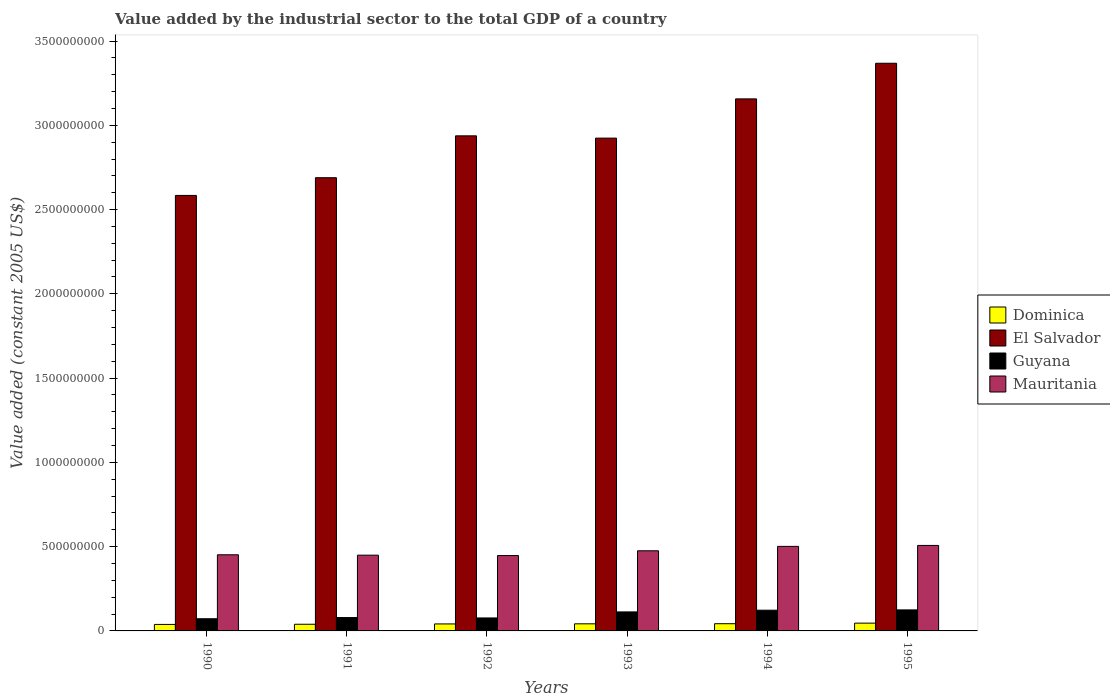How many different coloured bars are there?
Offer a very short reply. 4. How many groups of bars are there?
Your response must be concise. 6. Are the number of bars per tick equal to the number of legend labels?
Keep it short and to the point. Yes. Are the number of bars on each tick of the X-axis equal?
Ensure brevity in your answer.  Yes. How many bars are there on the 1st tick from the right?
Provide a succinct answer. 4. What is the label of the 1st group of bars from the left?
Ensure brevity in your answer.  1990. What is the value added by the industrial sector in Guyana in 1993?
Provide a succinct answer. 1.13e+08. Across all years, what is the maximum value added by the industrial sector in Mauritania?
Ensure brevity in your answer.  5.07e+08. Across all years, what is the minimum value added by the industrial sector in Guyana?
Your answer should be compact. 7.23e+07. What is the total value added by the industrial sector in Guyana in the graph?
Your response must be concise. 5.89e+08. What is the difference between the value added by the industrial sector in Guyana in 1992 and that in 1994?
Your answer should be very brief. -4.60e+07. What is the difference between the value added by the industrial sector in Dominica in 1992 and the value added by the industrial sector in Mauritania in 1995?
Offer a terse response. -4.66e+08. What is the average value added by the industrial sector in Guyana per year?
Make the answer very short. 9.82e+07. In the year 1995, what is the difference between the value added by the industrial sector in Guyana and value added by the industrial sector in Dominica?
Give a very brief answer. 7.85e+07. In how many years, is the value added by the industrial sector in Dominica greater than 2400000000 US$?
Provide a succinct answer. 0. What is the ratio of the value added by the industrial sector in El Salvador in 1991 to that in 1992?
Offer a terse response. 0.92. Is the value added by the industrial sector in Guyana in 1994 less than that in 1995?
Offer a very short reply. Yes. Is the difference between the value added by the industrial sector in Guyana in 1991 and 1993 greater than the difference between the value added by the industrial sector in Dominica in 1991 and 1993?
Keep it short and to the point. No. What is the difference between the highest and the second highest value added by the industrial sector in El Salvador?
Provide a short and direct response. 2.11e+08. What is the difference between the highest and the lowest value added by the industrial sector in El Salvador?
Your answer should be very brief. 7.84e+08. In how many years, is the value added by the industrial sector in Guyana greater than the average value added by the industrial sector in Guyana taken over all years?
Make the answer very short. 3. Is it the case that in every year, the sum of the value added by the industrial sector in Mauritania and value added by the industrial sector in Dominica is greater than the sum of value added by the industrial sector in Guyana and value added by the industrial sector in El Salvador?
Give a very brief answer. Yes. What does the 1st bar from the left in 1995 represents?
Your response must be concise. Dominica. What does the 3rd bar from the right in 1994 represents?
Ensure brevity in your answer.  El Salvador. Are all the bars in the graph horizontal?
Ensure brevity in your answer.  No. Does the graph contain any zero values?
Make the answer very short. No. Where does the legend appear in the graph?
Provide a short and direct response. Center right. How many legend labels are there?
Your response must be concise. 4. How are the legend labels stacked?
Offer a very short reply. Vertical. What is the title of the graph?
Ensure brevity in your answer.  Value added by the industrial sector to the total GDP of a country. Does "Small states" appear as one of the legend labels in the graph?
Ensure brevity in your answer.  No. What is the label or title of the X-axis?
Offer a terse response. Years. What is the label or title of the Y-axis?
Offer a very short reply. Value added (constant 2005 US$). What is the Value added (constant 2005 US$) of Dominica in 1990?
Provide a short and direct response. 3.85e+07. What is the Value added (constant 2005 US$) in El Salvador in 1990?
Offer a terse response. 2.58e+09. What is the Value added (constant 2005 US$) of Guyana in 1990?
Provide a succinct answer. 7.23e+07. What is the Value added (constant 2005 US$) of Mauritania in 1990?
Keep it short and to the point. 4.52e+08. What is the Value added (constant 2005 US$) of Dominica in 1991?
Provide a short and direct response. 3.95e+07. What is the Value added (constant 2005 US$) in El Salvador in 1991?
Your response must be concise. 2.69e+09. What is the Value added (constant 2005 US$) in Guyana in 1991?
Your answer should be very brief. 7.93e+07. What is the Value added (constant 2005 US$) in Mauritania in 1991?
Keep it short and to the point. 4.49e+08. What is the Value added (constant 2005 US$) in Dominica in 1992?
Keep it short and to the point. 4.14e+07. What is the Value added (constant 2005 US$) in El Salvador in 1992?
Give a very brief answer. 2.94e+09. What is the Value added (constant 2005 US$) in Guyana in 1992?
Provide a short and direct response. 7.70e+07. What is the Value added (constant 2005 US$) of Mauritania in 1992?
Your response must be concise. 4.47e+08. What is the Value added (constant 2005 US$) of Dominica in 1993?
Give a very brief answer. 4.22e+07. What is the Value added (constant 2005 US$) of El Salvador in 1993?
Offer a very short reply. 2.92e+09. What is the Value added (constant 2005 US$) of Guyana in 1993?
Give a very brief answer. 1.13e+08. What is the Value added (constant 2005 US$) of Mauritania in 1993?
Ensure brevity in your answer.  4.75e+08. What is the Value added (constant 2005 US$) of Dominica in 1994?
Offer a terse response. 4.28e+07. What is the Value added (constant 2005 US$) in El Salvador in 1994?
Your answer should be very brief. 3.16e+09. What is the Value added (constant 2005 US$) of Guyana in 1994?
Offer a terse response. 1.23e+08. What is the Value added (constant 2005 US$) of Mauritania in 1994?
Make the answer very short. 5.02e+08. What is the Value added (constant 2005 US$) of Dominica in 1995?
Offer a very short reply. 4.62e+07. What is the Value added (constant 2005 US$) in El Salvador in 1995?
Provide a short and direct response. 3.37e+09. What is the Value added (constant 2005 US$) of Guyana in 1995?
Ensure brevity in your answer.  1.25e+08. What is the Value added (constant 2005 US$) in Mauritania in 1995?
Make the answer very short. 5.07e+08. Across all years, what is the maximum Value added (constant 2005 US$) in Dominica?
Offer a very short reply. 4.62e+07. Across all years, what is the maximum Value added (constant 2005 US$) in El Salvador?
Your answer should be very brief. 3.37e+09. Across all years, what is the maximum Value added (constant 2005 US$) of Guyana?
Give a very brief answer. 1.25e+08. Across all years, what is the maximum Value added (constant 2005 US$) in Mauritania?
Offer a very short reply. 5.07e+08. Across all years, what is the minimum Value added (constant 2005 US$) of Dominica?
Your answer should be compact. 3.85e+07. Across all years, what is the minimum Value added (constant 2005 US$) in El Salvador?
Offer a very short reply. 2.58e+09. Across all years, what is the minimum Value added (constant 2005 US$) in Guyana?
Offer a terse response. 7.23e+07. Across all years, what is the minimum Value added (constant 2005 US$) in Mauritania?
Offer a terse response. 4.47e+08. What is the total Value added (constant 2005 US$) of Dominica in the graph?
Provide a short and direct response. 2.51e+08. What is the total Value added (constant 2005 US$) in El Salvador in the graph?
Your answer should be very brief. 1.77e+1. What is the total Value added (constant 2005 US$) in Guyana in the graph?
Your answer should be compact. 5.89e+08. What is the total Value added (constant 2005 US$) of Mauritania in the graph?
Offer a very short reply. 2.83e+09. What is the difference between the Value added (constant 2005 US$) of Dominica in 1990 and that in 1991?
Your response must be concise. -1.04e+06. What is the difference between the Value added (constant 2005 US$) in El Salvador in 1990 and that in 1991?
Provide a succinct answer. -1.05e+08. What is the difference between the Value added (constant 2005 US$) in Guyana in 1990 and that in 1991?
Provide a succinct answer. -7.01e+06. What is the difference between the Value added (constant 2005 US$) of Mauritania in 1990 and that in 1991?
Provide a short and direct response. 2.39e+06. What is the difference between the Value added (constant 2005 US$) in Dominica in 1990 and that in 1992?
Your response must be concise. -2.97e+06. What is the difference between the Value added (constant 2005 US$) of El Salvador in 1990 and that in 1992?
Your answer should be very brief. -3.54e+08. What is the difference between the Value added (constant 2005 US$) of Guyana in 1990 and that in 1992?
Provide a succinct answer. -4.70e+06. What is the difference between the Value added (constant 2005 US$) of Mauritania in 1990 and that in 1992?
Give a very brief answer. 4.77e+06. What is the difference between the Value added (constant 2005 US$) of Dominica in 1990 and that in 1993?
Your answer should be compact. -3.69e+06. What is the difference between the Value added (constant 2005 US$) of El Salvador in 1990 and that in 1993?
Your answer should be compact. -3.40e+08. What is the difference between the Value added (constant 2005 US$) of Guyana in 1990 and that in 1993?
Offer a very short reply. -4.05e+07. What is the difference between the Value added (constant 2005 US$) in Mauritania in 1990 and that in 1993?
Provide a succinct answer. -2.36e+07. What is the difference between the Value added (constant 2005 US$) in Dominica in 1990 and that in 1994?
Give a very brief answer. -4.34e+06. What is the difference between the Value added (constant 2005 US$) in El Salvador in 1990 and that in 1994?
Your answer should be very brief. -5.73e+08. What is the difference between the Value added (constant 2005 US$) of Guyana in 1990 and that in 1994?
Make the answer very short. -5.07e+07. What is the difference between the Value added (constant 2005 US$) of Mauritania in 1990 and that in 1994?
Give a very brief answer. -4.98e+07. What is the difference between the Value added (constant 2005 US$) of Dominica in 1990 and that in 1995?
Your answer should be very brief. -7.71e+06. What is the difference between the Value added (constant 2005 US$) in El Salvador in 1990 and that in 1995?
Your response must be concise. -7.84e+08. What is the difference between the Value added (constant 2005 US$) of Guyana in 1990 and that in 1995?
Offer a terse response. -5.24e+07. What is the difference between the Value added (constant 2005 US$) in Mauritania in 1990 and that in 1995?
Provide a short and direct response. -5.54e+07. What is the difference between the Value added (constant 2005 US$) of Dominica in 1991 and that in 1992?
Make the answer very short. -1.93e+06. What is the difference between the Value added (constant 2005 US$) of El Salvador in 1991 and that in 1992?
Your answer should be very brief. -2.48e+08. What is the difference between the Value added (constant 2005 US$) of Guyana in 1991 and that in 1992?
Keep it short and to the point. 2.31e+06. What is the difference between the Value added (constant 2005 US$) of Mauritania in 1991 and that in 1992?
Ensure brevity in your answer.  2.38e+06. What is the difference between the Value added (constant 2005 US$) in Dominica in 1991 and that in 1993?
Your answer should be compact. -2.65e+06. What is the difference between the Value added (constant 2005 US$) of El Salvador in 1991 and that in 1993?
Your answer should be compact. -2.35e+08. What is the difference between the Value added (constant 2005 US$) in Guyana in 1991 and that in 1993?
Offer a very short reply. -3.34e+07. What is the difference between the Value added (constant 2005 US$) in Mauritania in 1991 and that in 1993?
Make the answer very short. -2.60e+07. What is the difference between the Value added (constant 2005 US$) in Dominica in 1991 and that in 1994?
Your answer should be compact. -3.30e+06. What is the difference between the Value added (constant 2005 US$) in El Salvador in 1991 and that in 1994?
Give a very brief answer. -4.68e+08. What is the difference between the Value added (constant 2005 US$) in Guyana in 1991 and that in 1994?
Your answer should be compact. -4.36e+07. What is the difference between the Value added (constant 2005 US$) in Mauritania in 1991 and that in 1994?
Offer a very short reply. -5.22e+07. What is the difference between the Value added (constant 2005 US$) of Dominica in 1991 and that in 1995?
Provide a short and direct response. -6.67e+06. What is the difference between the Value added (constant 2005 US$) in El Salvador in 1991 and that in 1995?
Your answer should be very brief. -6.79e+08. What is the difference between the Value added (constant 2005 US$) in Guyana in 1991 and that in 1995?
Keep it short and to the point. -4.54e+07. What is the difference between the Value added (constant 2005 US$) of Mauritania in 1991 and that in 1995?
Offer a terse response. -5.78e+07. What is the difference between the Value added (constant 2005 US$) of Dominica in 1992 and that in 1993?
Keep it short and to the point. -7.15e+05. What is the difference between the Value added (constant 2005 US$) of El Salvador in 1992 and that in 1993?
Provide a short and direct response. 1.35e+07. What is the difference between the Value added (constant 2005 US$) in Guyana in 1992 and that in 1993?
Your answer should be very brief. -3.58e+07. What is the difference between the Value added (constant 2005 US$) of Mauritania in 1992 and that in 1993?
Offer a terse response. -2.84e+07. What is the difference between the Value added (constant 2005 US$) in Dominica in 1992 and that in 1994?
Ensure brevity in your answer.  -1.36e+06. What is the difference between the Value added (constant 2005 US$) of El Salvador in 1992 and that in 1994?
Offer a very short reply. -2.19e+08. What is the difference between the Value added (constant 2005 US$) of Guyana in 1992 and that in 1994?
Your response must be concise. -4.60e+07. What is the difference between the Value added (constant 2005 US$) in Mauritania in 1992 and that in 1994?
Give a very brief answer. -5.45e+07. What is the difference between the Value added (constant 2005 US$) of Dominica in 1992 and that in 1995?
Make the answer very short. -4.74e+06. What is the difference between the Value added (constant 2005 US$) in El Salvador in 1992 and that in 1995?
Provide a succinct answer. -4.31e+08. What is the difference between the Value added (constant 2005 US$) in Guyana in 1992 and that in 1995?
Your answer should be compact. -4.77e+07. What is the difference between the Value added (constant 2005 US$) of Mauritania in 1992 and that in 1995?
Provide a short and direct response. -6.01e+07. What is the difference between the Value added (constant 2005 US$) in Dominica in 1993 and that in 1994?
Offer a very short reply. -6.48e+05. What is the difference between the Value added (constant 2005 US$) of El Salvador in 1993 and that in 1994?
Make the answer very short. -2.33e+08. What is the difference between the Value added (constant 2005 US$) in Guyana in 1993 and that in 1994?
Offer a very short reply. -1.02e+07. What is the difference between the Value added (constant 2005 US$) in Mauritania in 1993 and that in 1994?
Offer a very short reply. -2.61e+07. What is the difference between the Value added (constant 2005 US$) in Dominica in 1993 and that in 1995?
Ensure brevity in your answer.  -4.02e+06. What is the difference between the Value added (constant 2005 US$) in El Salvador in 1993 and that in 1995?
Your answer should be very brief. -4.44e+08. What is the difference between the Value added (constant 2005 US$) of Guyana in 1993 and that in 1995?
Ensure brevity in your answer.  -1.20e+07. What is the difference between the Value added (constant 2005 US$) in Mauritania in 1993 and that in 1995?
Make the answer very short. -3.18e+07. What is the difference between the Value added (constant 2005 US$) of Dominica in 1994 and that in 1995?
Keep it short and to the point. -3.37e+06. What is the difference between the Value added (constant 2005 US$) in El Salvador in 1994 and that in 1995?
Your answer should be compact. -2.11e+08. What is the difference between the Value added (constant 2005 US$) of Guyana in 1994 and that in 1995?
Offer a very short reply. -1.77e+06. What is the difference between the Value added (constant 2005 US$) in Mauritania in 1994 and that in 1995?
Provide a succinct answer. -5.62e+06. What is the difference between the Value added (constant 2005 US$) in Dominica in 1990 and the Value added (constant 2005 US$) in El Salvador in 1991?
Provide a succinct answer. -2.65e+09. What is the difference between the Value added (constant 2005 US$) of Dominica in 1990 and the Value added (constant 2005 US$) of Guyana in 1991?
Give a very brief answer. -4.08e+07. What is the difference between the Value added (constant 2005 US$) of Dominica in 1990 and the Value added (constant 2005 US$) of Mauritania in 1991?
Give a very brief answer. -4.11e+08. What is the difference between the Value added (constant 2005 US$) in El Salvador in 1990 and the Value added (constant 2005 US$) in Guyana in 1991?
Your response must be concise. 2.50e+09. What is the difference between the Value added (constant 2005 US$) of El Salvador in 1990 and the Value added (constant 2005 US$) of Mauritania in 1991?
Your answer should be very brief. 2.13e+09. What is the difference between the Value added (constant 2005 US$) of Guyana in 1990 and the Value added (constant 2005 US$) of Mauritania in 1991?
Your answer should be compact. -3.77e+08. What is the difference between the Value added (constant 2005 US$) in Dominica in 1990 and the Value added (constant 2005 US$) in El Salvador in 1992?
Provide a short and direct response. -2.90e+09. What is the difference between the Value added (constant 2005 US$) in Dominica in 1990 and the Value added (constant 2005 US$) in Guyana in 1992?
Provide a succinct answer. -3.85e+07. What is the difference between the Value added (constant 2005 US$) of Dominica in 1990 and the Value added (constant 2005 US$) of Mauritania in 1992?
Give a very brief answer. -4.09e+08. What is the difference between the Value added (constant 2005 US$) of El Salvador in 1990 and the Value added (constant 2005 US$) of Guyana in 1992?
Your answer should be very brief. 2.51e+09. What is the difference between the Value added (constant 2005 US$) in El Salvador in 1990 and the Value added (constant 2005 US$) in Mauritania in 1992?
Provide a succinct answer. 2.14e+09. What is the difference between the Value added (constant 2005 US$) in Guyana in 1990 and the Value added (constant 2005 US$) in Mauritania in 1992?
Ensure brevity in your answer.  -3.75e+08. What is the difference between the Value added (constant 2005 US$) of Dominica in 1990 and the Value added (constant 2005 US$) of El Salvador in 1993?
Keep it short and to the point. -2.89e+09. What is the difference between the Value added (constant 2005 US$) of Dominica in 1990 and the Value added (constant 2005 US$) of Guyana in 1993?
Your response must be concise. -7.43e+07. What is the difference between the Value added (constant 2005 US$) in Dominica in 1990 and the Value added (constant 2005 US$) in Mauritania in 1993?
Offer a terse response. -4.37e+08. What is the difference between the Value added (constant 2005 US$) of El Salvador in 1990 and the Value added (constant 2005 US$) of Guyana in 1993?
Offer a very short reply. 2.47e+09. What is the difference between the Value added (constant 2005 US$) in El Salvador in 1990 and the Value added (constant 2005 US$) in Mauritania in 1993?
Provide a succinct answer. 2.11e+09. What is the difference between the Value added (constant 2005 US$) in Guyana in 1990 and the Value added (constant 2005 US$) in Mauritania in 1993?
Give a very brief answer. -4.03e+08. What is the difference between the Value added (constant 2005 US$) in Dominica in 1990 and the Value added (constant 2005 US$) in El Salvador in 1994?
Keep it short and to the point. -3.12e+09. What is the difference between the Value added (constant 2005 US$) in Dominica in 1990 and the Value added (constant 2005 US$) in Guyana in 1994?
Give a very brief answer. -8.45e+07. What is the difference between the Value added (constant 2005 US$) in Dominica in 1990 and the Value added (constant 2005 US$) in Mauritania in 1994?
Your response must be concise. -4.63e+08. What is the difference between the Value added (constant 2005 US$) of El Salvador in 1990 and the Value added (constant 2005 US$) of Guyana in 1994?
Offer a terse response. 2.46e+09. What is the difference between the Value added (constant 2005 US$) in El Salvador in 1990 and the Value added (constant 2005 US$) in Mauritania in 1994?
Make the answer very short. 2.08e+09. What is the difference between the Value added (constant 2005 US$) in Guyana in 1990 and the Value added (constant 2005 US$) in Mauritania in 1994?
Make the answer very short. -4.29e+08. What is the difference between the Value added (constant 2005 US$) of Dominica in 1990 and the Value added (constant 2005 US$) of El Salvador in 1995?
Your answer should be very brief. -3.33e+09. What is the difference between the Value added (constant 2005 US$) in Dominica in 1990 and the Value added (constant 2005 US$) in Guyana in 1995?
Your answer should be very brief. -8.63e+07. What is the difference between the Value added (constant 2005 US$) of Dominica in 1990 and the Value added (constant 2005 US$) of Mauritania in 1995?
Ensure brevity in your answer.  -4.69e+08. What is the difference between the Value added (constant 2005 US$) of El Salvador in 1990 and the Value added (constant 2005 US$) of Guyana in 1995?
Provide a succinct answer. 2.46e+09. What is the difference between the Value added (constant 2005 US$) in El Salvador in 1990 and the Value added (constant 2005 US$) in Mauritania in 1995?
Offer a terse response. 2.08e+09. What is the difference between the Value added (constant 2005 US$) in Guyana in 1990 and the Value added (constant 2005 US$) in Mauritania in 1995?
Offer a very short reply. -4.35e+08. What is the difference between the Value added (constant 2005 US$) in Dominica in 1991 and the Value added (constant 2005 US$) in El Salvador in 1992?
Give a very brief answer. -2.90e+09. What is the difference between the Value added (constant 2005 US$) of Dominica in 1991 and the Value added (constant 2005 US$) of Guyana in 1992?
Offer a terse response. -3.75e+07. What is the difference between the Value added (constant 2005 US$) in Dominica in 1991 and the Value added (constant 2005 US$) in Mauritania in 1992?
Keep it short and to the point. -4.08e+08. What is the difference between the Value added (constant 2005 US$) in El Salvador in 1991 and the Value added (constant 2005 US$) in Guyana in 1992?
Give a very brief answer. 2.61e+09. What is the difference between the Value added (constant 2005 US$) of El Salvador in 1991 and the Value added (constant 2005 US$) of Mauritania in 1992?
Your answer should be very brief. 2.24e+09. What is the difference between the Value added (constant 2005 US$) in Guyana in 1991 and the Value added (constant 2005 US$) in Mauritania in 1992?
Your answer should be very brief. -3.68e+08. What is the difference between the Value added (constant 2005 US$) in Dominica in 1991 and the Value added (constant 2005 US$) in El Salvador in 1993?
Make the answer very short. -2.88e+09. What is the difference between the Value added (constant 2005 US$) of Dominica in 1991 and the Value added (constant 2005 US$) of Guyana in 1993?
Provide a succinct answer. -7.32e+07. What is the difference between the Value added (constant 2005 US$) in Dominica in 1991 and the Value added (constant 2005 US$) in Mauritania in 1993?
Your answer should be compact. -4.36e+08. What is the difference between the Value added (constant 2005 US$) in El Salvador in 1991 and the Value added (constant 2005 US$) in Guyana in 1993?
Your answer should be compact. 2.58e+09. What is the difference between the Value added (constant 2005 US$) of El Salvador in 1991 and the Value added (constant 2005 US$) of Mauritania in 1993?
Ensure brevity in your answer.  2.21e+09. What is the difference between the Value added (constant 2005 US$) of Guyana in 1991 and the Value added (constant 2005 US$) of Mauritania in 1993?
Keep it short and to the point. -3.96e+08. What is the difference between the Value added (constant 2005 US$) of Dominica in 1991 and the Value added (constant 2005 US$) of El Salvador in 1994?
Keep it short and to the point. -3.12e+09. What is the difference between the Value added (constant 2005 US$) in Dominica in 1991 and the Value added (constant 2005 US$) in Guyana in 1994?
Ensure brevity in your answer.  -8.34e+07. What is the difference between the Value added (constant 2005 US$) in Dominica in 1991 and the Value added (constant 2005 US$) in Mauritania in 1994?
Provide a short and direct response. -4.62e+08. What is the difference between the Value added (constant 2005 US$) in El Salvador in 1991 and the Value added (constant 2005 US$) in Guyana in 1994?
Your response must be concise. 2.57e+09. What is the difference between the Value added (constant 2005 US$) in El Salvador in 1991 and the Value added (constant 2005 US$) in Mauritania in 1994?
Keep it short and to the point. 2.19e+09. What is the difference between the Value added (constant 2005 US$) in Guyana in 1991 and the Value added (constant 2005 US$) in Mauritania in 1994?
Offer a very short reply. -4.22e+08. What is the difference between the Value added (constant 2005 US$) in Dominica in 1991 and the Value added (constant 2005 US$) in El Salvador in 1995?
Keep it short and to the point. -3.33e+09. What is the difference between the Value added (constant 2005 US$) of Dominica in 1991 and the Value added (constant 2005 US$) of Guyana in 1995?
Your answer should be very brief. -8.52e+07. What is the difference between the Value added (constant 2005 US$) in Dominica in 1991 and the Value added (constant 2005 US$) in Mauritania in 1995?
Make the answer very short. -4.68e+08. What is the difference between the Value added (constant 2005 US$) of El Salvador in 1991 and the Value added (constant 2005 US$) of Guyana in 1995?
Offer a terse response. 2.56e+09. What is the difference between the Value added (constant 2005 US$) in El Salvador in 1991 and the Value added (constant 2005 US$) in Mauritania in 1995?
Your answer should be compact. 2.18e+09. What is the difference between the Value added (constant 2005 US$) in Guyana in 1991 and the Value added (constant 2005 US$) in Mauritania in 1995?
Make the answer very short. -4.28e+08. What is the difference between the Value added (constant 2005 US$) in Dominica in 1992 and the Value added (constant 2005 US$) in El Salvador in 1993?
Offer a very short reply. -2.88e+09. What is the difference between the Value added (constant 2005 US$) in Dominica in 1992 and the Value added (constant 2005 US$) in Guyana in 1993?
Offer a terse response. -7.13e+07. What is the difference between the Value added (constant 2005 US$) in Dominica in 1992 and the Value added (constant 2005 US$) in Mauritania in 1993?
Keep it short and to the point. -4.34e+08. What is the difference between the Value added (constant 2005 US$) of El Salvador in 1992 and the Value added (constant 2005 US$) of Guyana in 1993?
Provide a succinct answer. 2.82e+09. What is the difference between the Value added (constant 2005 US$) of El Salvador in 1992 and the Value added (constant 2005 US$) of Mauritania in 1993?
Your answer should be very brief. 2.46e+09. What is the difference between the Value added (constant 2005 US$) in Guyana in 1992 and the Value added (constant 2005 US$) in Mauritania in 1993?
Make the answer very short. -3.98e+08. What is the difference between the Value added (constant 2005 US$) of Dominica in 1992 and the Value added (constant 2005 US$) of El Salvador in 1994?
Keep it short and to the point. -3.12e+09. What is the difference between the Value added (constant 2005 US$) in Dominica in 1992 and the Value added (constant 2005 US$) in Guyana in 1994?
Give a very brief answer. -8.15e+07. What is the difference between the Value added (constant 2005 US$) in Dominica in 1992 and the Value added (constant 2005 US$) in Mauritania in 1994?
Offer a terse response. -4.60e+08. What is the difference between the Value added (constant 2005 US$) in El Salvador in 1992 and the Value added (constant 2005 US$) in Guyana in 1994?
Keep it short and to the point. 2.81e+09. What is the difference between the Value added (constant 2005 US$) of El Salvador in 1992 and the Value added (constant 2005 US$) of Mauritania in 1994?
Offer a terse response. 2.44e+09. What is the difference between the Value added (constant 2005 US$) of Guyana in 1992 and the Value added (constant 2005 US$) of Mauritania in 1994?
Your response must be concise. -4.25e+08. What is the difference between the Value added (constant 2005 US$) of Dominica in 1992 and the Value added (constant 2005 US$) of El Salvador in 1995?
Your answer should be very brief. -3.33e+09. What is the difference between the Value added (constant 2005 US$) of Dominica in 1992 and the Value added (constant 2005 US$) of Guyana in 1995?
Offer a terse response. -8.33e+07. What is the difference between the Value added (constant 2005 US$) in Dominica in 1992 and the Value added (constant 2005 US$) in Mauritania in 1995?
Your response must be concise. -4.66e+08. What is the difference between the Value added (constant 2005 US$) of El Salvador in 1992 and the Value added (constant 2005 US$) of Guyana in 1995?
Your answer should be very brief. 2.81e+09. What is the difference between the Value added (constant 2005 US$) of El Salvador in 1992 and the Value added (constant 2005 US$) of Mauritania in 1995?
Provide a short and direct response. 2.43e+09. What is the difference between the Value added (constant 2005 US$) in Guyana in 1992 and the Value added (constant 2005 US$) in Mauritania in 1995?
Give a very brief answer. -4.30e+08. What is the difference between the Value added (constant 2005 US$) in Dominica in 1993 and the Value added (constant 2005 US$) in El Salvador in 1994?
Make the answer very short. -3.11e+09. What is the difference between the Value added (constant 2005 US$) in Dominica in 1993 and the Value added (constant 2005 US$) in Guyana in 1994?
Your answer should be very brief. -8.08e+07. What is the difference between the Value added (constant 2005 US$) in Dominica in 1993 and the Value added (constant 2005 US$) in Mauritania in 1994?
Offer a very short reply. -4.59e+08. What is the difference between the Value added (constant 2005 US$) in El Salvador in 1993 and the Value added (constant 2005 US$) in Guyana in 1994?
Offer a terse response. 2.80e+09. What is the difference between the Value added (constant 2005 US$) of El Salvador in 1993 and the Value added (constant 2005 US$) of Mauritania in 1994?
Provide a short and direct response. 2.42e+09. What is the difference between the Value added (constant 2005 US$) of Guyana in 1993 and the Value added (constant 2005 US$) of Mauritania in 1994?
Offer a terse response. -3.89e+08. What is the difference between the Value added (constant 2005 US$) of Dominica in 1993 and the Value added (constant 2005 US$) of El Salvador in 1995?
Provide a succinct answer. -3.33e+09. What is the difference between the Value added (constant 2005 US$) in Dominica in 1993 and the Value added (constant 2005 US$) in Guyana in 1995?
Your response must be concise. -8.26e+07. What is the difference between the Value added (constant 2005 US$) in Dominica in 1993 and the Value added (constant 2005 US$) in Mauritania in 1995?
Make the answer very short. -4.65e+08. What is the difference between the Value added (constant 2005 US$) in El Salvador in 1993 and the Value added (constant 2005 US$) in Guyana in 1995?
Offer a terse response. 2.80e+09. What is the difference between the Value added (constant 2005 US$) of El Salvador in 1993 and the Value added (constant 2005 US$) of Mauritania in 1995?
Keep it short and to the point. 2.42e+09. What is the difference between the Value added (constant 2005 US$) in Guyana in 1993 and the Value added (constant 2005 US$) in Mauritania in 1995?
Your response must be concise. -3.94e+08. What is the difference between the Value added (constant 2005 US$) of Dominica in 1994 and the Value added (constant 2005 US$) of El Salvador in 1995?
Keep it short and to the point. -3.33e+09. What is the difference between the Value added (constant 2005 US$) in Dominica in 1994 and the Value added (constant 2005 US$) in Guyana in 1995?
Offer a very short reply. -8.19e+07. What is the difference between the Value added (constant 2005 US$) in Dominica in 1994 and the Value added (constant 2005 US$) in Mauritania in 1995?
Ensure brevity in your answer.  -4.64e+08. What is the difference between the Value added (constant 2005 US$) of El Salvador in 1994 and the Value added (constant 2005 US$) of Guyana in 1995?
Your answer should be compact. 3.03e+09. What is the difference between the Value added (constant 2005 US$) in El Salvador in 1994 and the Value added (constant 2005 US$) in Mauritania in 1995?
Provide a short and direct response. 2.65e+09. What is the difference between the Value added (constant 2005 US$) of Guyana in 1994 and the Value added (constant 2005 US$) of Mauritania in 1995?
Your answer should be very brief. -3.84e+08. What is the average Value added (constant 2005 US$) in Dominica per year?
Make the answer very short. 4.18e+07. What is the average Value added (constant 2005 US$) in El Salvador per year?
Your response must be concise. 2.94e+09. What is the average Value added (constant 2005 US$) of Guyana per year?
Ensure brevity in your answer.  9.82e+07. What is the average Value added (constant 2005 US$) of Mauritania per year?
Make the answer very short. 4.72e+08. In the year 1990, what is the difference between the Value added (constant 2005 US$) of Dominica and Value added (constant 2005 US$) of El Salvador?
Make the answer very short. -2.55e+09. In the year 1990, what is the difference between the Value added (constant 2005 US$) in Dominica and Value added (constant 2005 US$) in Guyana?
Offer a very short reply. -3.38e+07. In the year 1990, what is the difference between the Value added (constant 2005 US$) in Dominica and Value added (constant 2005 US$) in Mauritania?
Your answer should be very brief. -4.13e+08. In the year 1990, what is the difference between the Value added (constant 2005 US$) in El Salvador and Value added (constant 2005 US$) in Guyana?
Keep it short and to the point. 2.51e+09. In the year 1990, what is the difference between the Value added (constant 2005 US$) in El Salvador and Value added (constant 2005 US$) in Mauritania?
Ensure brevity in your answer.  2.13e+09. In the year 1990, what is the difference between the Value added (constant 2005 US$) of Guyana and Value added (constant 2005 US$) of Mauritania?
Ensure brevity in your answer.  -3.80e+08. In the year 1991, what is the difference between the Value added (constant 2005 US$) of Dominica and Value added (constant 2005 US$) of El Salvador?
Provide a short and direct response. -2.65e+09. In the year 1991, what is the difference between the Value added (constant 2005 US$) in Dominica and Value added (constant 2005 US$) in Guyana?
Make the answer very short. -3.98e+07. In the year 1991, what is the difference between the Value added (constant 2005 US$) of Dominica and Value added (constant 2005 US$) of Mauritania?
Provide a short and direct response. -4.10e+08. In the year 1991, what is the difference between the Value added (constant 2005 US$) of El Salvador and Value added (constant 2005 US$) of Guyana?
Make the answer very short. 2.61e+09. In the year 1991, what is the difference between the Value added (constant 2005 US$) in El Salvador and Value added (constant 2005 US$) in Mauritania?
Your response must be concise. 2.24e+09. In the year 1991, what is the difference between the Value added (constant 2005 US$) of Guyana and Value added (constant 2005 US$) of Mauritania?
Keep it short and to the point. -3.70e+08. In the year 1992, what is the difference between the Value added (constant 2005 US$) of Dominica and Value added (constant 2005 US$) of El Salvador?
Your answer should be compact. -2.90e+09. In the year 1992, what is the difference between the Value added (constant 2005 US$) of Dominica and Value added (constant 2005 US$) of Guyana?
Keep it short and to the point. -3.56e+07. In the year 1992, what is the difference between the Value added (constant 2005 US$) in Dominica and Value added (constant 2005 US$) in Mauritania?
Give a very brief answer. -4.06e+08. In the year 1992, what is the difference between the Value added (constant 2005 US$) of El Salvador and Value added (constant 2005 US$) of Guyana?
Ensure brevity in your answer.  2.86e+09. In the year 1992, what is the difference between the Value added (constant 2005 US$) in El Salvador and Value added (constant 2005 US$) in Mauritania?
Your answer should be very brief. 2.49e+09. In the year 1992, what is the difference between the Value added (constant 2005 US$) in Guyana and Value added (constant 2005 US$) in Mauritania?
Keep it short and to the point. -3.70e+08. In the year 1993, what is the difference between the Value added (constant 2005 US$) in Dominica and Value added (constant 2005 US$) in El Salvador?
Provide a succinct answer. -2.88e+09. In the year 1993, what is the difference between the Value added (constant 2005 US$) in Dominica and Value added (constant 2005 US$) in Guyana?
Give a very brief answer. -7.06e+07. In the year 1993, what is the difference between the Value added (constant 2005 US$) in Dominica and Value added (constant 2005 US$) in Mauritania?
Offer a very short reply. -4.33e+08. In the year 1993, what is the difference between the Value added (constant 2005 US$) of El Salvador and Value added (constant 2005 US$) of Guyana?
Ensure brevity in your answer.  2.81e+09. In the year 1993, what is the difference between the Value added (constant 2005 US$) of El Salvador and Value added (constant 2005 US$) of Mauritania?
Give a very brief answer. 2.45e+09. In the year 1993, what is the difference between the Value added (constant 2005 US$) in Guyana and Value added (constant 2005 US$) in Mauritania?
Offer a very short reply. -3.63e+08. In the year 1994, what is the difference between the Value added (constant 2005 US$) of Dominica and Value added (constant 2005 US$) of El Salvador?
Ensure brevity in your answer.  -3.11e+09. In the year 1994, what is the difference between the Value added (constant 2005 US$) in Dominica and Value added (constant 2005 US$) in Guyana?
Your answer should be compact. -8.01e+07. In the year 1994, what is the difference between the Value added (constant 2005 US$) in Dominica and Value added (constant 2005 US$) in Mauritania?
Keep it short and to the point. -4.59e+08. In the year 1994, what is the difference between the Value added (constant 2005 US$) in El Salvador and Value added (constant 2005 US$) in Guyana?
Provide a short and direct response. 3.03e+09. In the year 1994, what is the difference between the Value added (constant 2005 US$) of El Salvador and Value added (constant 2005 US$) of Mauritania?
Your answer should be compact. 2.66e+09. In the year 1994, what is the difference between the Value added (constant 2005 US$) of Guyana and Value added (constant 2005 US$) of Mauritania?
Make the answer very short. -3.79e+08. In the year 1995, what is the difference between the Value added (constant 2005 US$) in Dominica and Value added (constant 2005 US$) in El Salvador?
Offer a terse response. -3.32e+09. In the year 1995, what is the difference between the Value added (constant 2005 US$) of Dominica and Value added (constant 2005 US$) of Guyana?
Offer a very short reply. -7.85e+07. In the year 1995, what is the difference between the Value added (constant 2005 US$) in Dominica and Value added (constant 2005 US$) in Mauritania?
Offer a terse response. -4.61e+08. In the year 1995, what is the difference between the Value added (constant 2005 US$) in El Salvador and Value added (constant 2005 US$) in Guyana?
Provide a succinct answer. 3.24e+09. In the year 1995, what is the difference between the Value added (constant 2005 US$) in El Salvador and Value added (constant 2005 US$) in Mauritania?
Provide a short and direct response. 2.86e+09. In the year 1995, what is the difference between the Value added (constant 2005 US$) in Guyana and Value added (constant 2005 US$) in Mauritania?
Keep it short and to the point. -3.82e+08. What is the ratio of the Value added (constant 2005 US$) in Dominica in 1990 to that in 1991?
Ensure brevity in your answer.  0.97. What is the ratio of the Value added (constant 2005 US$) in El Salvador in 1990 to that in 1991?
Your answer should be very brief. 0.96. What is the ratio of the Value added (constant 2005 US$) of Guyana in 1990 to that in 1991?
Your answer should be compact. 0.91. What is the ratio of the Value added (constant 2005 US$) of Dominica in 1990 to that in 1992?
Your answer should be compact. 0.93. What is the ratio of the Value added (constant 2005 US$) in El Salvador in 1990 to that in 1992?
Keep it short and to the point. 0.88. What is the ratio of the Value added (constant 2005 US$) in Guyana in 1990 to that in 1992?
Provide a short and direct response. 0.94. What is the ratio of the Value added (constant 2005 US$) in Mauritania in 1990 to that in 1992?
Your response must be concise. 1.01. What is the ratio of the Value added (constant 2005 US$) in Dominica in 1990 to that in 1993?
Ensure brevity in your answer.  0.91. What is the ratio of the Value added (constant 2005 US$) of El Salvador in 1990 to that in 1993?
Provide a succinct answer. 0.88. What is the ratio of the Value added (constant 2005 US$) of Guyana in 1990 to that in 1993?
Your response must be concise. 0.64. What is the ratio of the Value added (constant 2005 US$) in Mauritania in 1990 to that in 1993?
Keep it short and to the point. 0.95. What is the ratio of the Value added (constant 2005 US$) in Dominica in 1990 to that in 1994?
Your answer should be compact. 0.9. What is the ratio of the Value added (constant 2005 US$) in El Salvador in 1990 to that in 1994?
Provide a short and direct response. 0.82. What is the ratio of the Value added (constant 2005 US$) of Guyana in 1990 to that in 1994?
Provide a succinct answer. 0.59. What is the ratio of the Value added (constant 2005 US$) of Mauritania in 1990 to that in 1994?
Ensure brevity in your answer.  0.9. What is the ratio of the Value added (constant 2005 US$) in Dominica in 1990 to that in 1995?
Make the answer very short. 0.83. What is the ratio of the Value added (constant 2005 US$) in El Salvador in 1990 to that in 1995?
Provide a short and direct response. 0.77. What is the ratio of the Value added (constant 2005 US$) in Guyana in 1990 to that in 1995?
Provide a succinct answer. 0.58. What is the ratio of the Value added (constant 2005 US$) of Mauritania in 1990 to that in 1995?
Give a very brief answer. 0.89. What is the ratio of the Value added (constant 2005 US$) of Dominica in 1991 to that in 1992?
Keep it short and to the point. 0.95. What is the ratio of the Value added (constant 2005 US$) of El Salvador in 1991 to that in 1992?
Make the answer very short. 0.92. What is the ratio of the Value added (constant 2005 US$) of Guyana in 1991 to that in 1992?
Ensure brevity in your answer.  1.03. What is the ratio of the Value added (constant 2005 US$) in Mauritania in 1991 to that in 1992?
Ensure brevity in your answer.  1.01. What is the ratio of the Value added (constant 2005 US$) in Dominica in 1991 to that in 1993?
Your answer should be very brief. 0.94. What is the ratio of the Value added (constant 2005 US$) of El Salvador in 1991 to that in 1993?
Ensure brevity in your answer.  0.92. What is the ratio of the Value added (constant 2005 US$) of Guyana in 1991 to that in 1993?
Ensure brevity in your answer.  0.7. What is the ratio of the Value added (constant 2005 US$) in Mauritania in 1991 to that in 1993?
Your answer should be compact. 0.95. What is the ratio of the Value added (constant 2005 US$) in Dominica in 1991 to that in 1994?
Keep it short and to the point. 0.92. What is the ratio of the Value added (constant 2005 US$) of El Salvador in 1991 to that in 1994?
Provide a short and direct response. 0.85. What is the ratio of the Value added (constant 2005 US$) of Guyana in 1991 to that in 1994?
Your answer should be very brief. 0.65. What is the ratio of the Value added (constant 2005 US$) of Mauritania in 1991 to that in 1994?
Your answer should be very brief. 0.9. What is the ratio of the Value added (constant 2005 US$) in Dominica in 1991 to that in 1995?
Your answer should be very brief. 0.86. What is the ratio of the Value added (constant 2005 US$) of El Salvador in 1991 to that in 1995?
Ensure brevity in your answer.  0.8. What is the ratio of the Value added (constant 2005 US$) of Guyana in 1991 to that in 1995?
Make the answer very short. 0.64. What is the ratio of the Value added (constant 2005 US$) in Mauritania in 1991 to that in 1995?
Offer a terse response. 0.89. What is the ratio of the Value added (constant 2005 US$) of El Salvador in 1992 to that in 1993?
Your answer should be very brief. 1. What is the ratio of the Value added (constant 2005 US$) of Guyana in 1992 to that in 1993?
Offer a terse response. 0.68. What is the ratio of the Value added (constant 2005 US$) of Mauritania in 1992 to that in 1993?
Make the answer very short. 0.94. What is the ratio of the Value added (constant 2005 US$) in Dominica in 1992 to that in 1994?
Make the answer very short. 0.97. What is the ratio of the Value added (constant 2005 US$) in El Salvador in 1992 to that in 1994?
Your answer should be compact. 0.93. What is the ratio of the Value added (constant 2005 US$) in Guyana in 1992 to that in 1994?
Provide a short and direct response. 0.63. What is the ratio of the Value added (constant 2005 US$) in Mauritania in 1992 to that in 1994?
Offer a very short reply. 0.89. What is the ratio of the Value added (constant 2005 US$) in Dominica in 1992 to that in 1995?
Keep it short and to the point. 0.9. What is the ratio of the Value added (constant 2005 US$) in El Salvador in 1992 to that in 1995?
Keep it short and to the point. 0.87. What is the ratio of the Value added (constant 2005 US$) in Guyana in 1992 to that in 1995?
Ensure brevity in your answer.  0.62. What is the ratio of the Value added (constant 2005 US$) of Mauritania in 1992 to that in 1995?
Provide a succinct answer. 0.88. What is the ratio of the Value added (constant 2005 US$) of Dominica in 1993 to that in 1994?
Offer a very short reply. 0.98. What is the ratio of the Value added (constant 2005 US$) in El Salvador in 1993 to that in 1994?
Provide a short and direct response. 0.93. What is the ratio of the Value added (constant 2005 US$) of Guyana in 1993 to that in 1994?
Offer a terse response. 0.92. What is the ratio of the Value added (constant 2005 US$) in Mauritania in 1993 to that in 1994?
Your answer should be compact. 0.95. What is the ratio of the Value added (constant 2005 US$) of Dominica in 1993 to that in 1995?
Provide a short and direct response. 0.91. What is the ratio of the Value added (constant 2005 US$) in El Salvador in 1993 to that in 1995?
Ensure brevity in your answer.  0.87. What is the ratio of the Value added (constant 2005 US$) of Guyana in 1993 to that in 1995?
Offer a terse response. 0.9. What is the ratio of the Value added (constant 2005 US$) in Mauritania in 1993 to that in 1995?
Your answer should be very brief. 0.94. What is the ratio of the Value added (constant 2005 US$) of Dominica in 1994 to that in 1995?
Make the answer very short. 0.93. What is the ratio of the Value added (constant 2005 US$) of El Salvador in 1994 to that in 1995?
Provide a succinct answer. 0.94. What is the ratio of the Value added (constant 2005 US$) in Guyana in 1994 to that in 1995?
Offer a terse response. 0.99. What is the ratio of the Value added (constant 2005 US$) of Mauritania in 1994 to that in 1995?
Your answer should be very brief. 0.99. What is the difference between the highest and the second highest Value added (constant 2005 US$) in Dominica?
Offer a terse response. 3.37e+06. What is the difference between the highest and the second highest Value added (constant 2005 US$) in El Salvador?
Provide a succinct answer. 2.11e+08. What is the difference between the highest and the second highest Value added (constant 2005 US$) in Guyana?
Offer a very short reply. 1.77e+06. What is the difference between the highest and the second highest Value added (constant 2005 US$) of Mauritania?
Keep it short and to the point. 5.62e+06. What is the difference between the highest and the lowest Value added (constant 2005 US$) in Dominica?
Offer a terse response. 7.71e+06. What is the difference between the highest and the lowest Value added (constant 2005 US$) of El Salvador?
Your answer should be compact. 7.84e+08. What is the difference between the highest and the lowest Value added (constant 2005 US$) of Guyana?
Offer a very short reply. 5.24e+07. What is the difference between the highest and the lowest Value added (constant 2005 US$) in Mauritania?
Your response must be concise. 6.01e+07. 